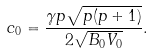Convert formula to latex. <formula><loc_0><loc_0><loc_500><loc_500>c _ { 0 } = \frac { \gamma p \sqrt { p ( p + 1 ) } } { 2 \sqrt { B _ { 0 } V _ { 0 } } } .</formula> 